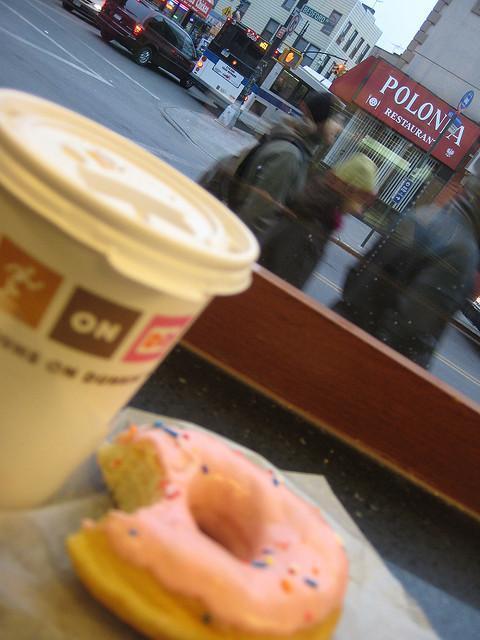How many people are walking by?
Give a very brief answer. 3. How many people can be seen?
Give a very brief answer. 3. How many backpacks can be seen?
Give a very brief answer. 2. How many signs are hanging above the toilet that are not written in english?
Give a very brief answer. 0. 